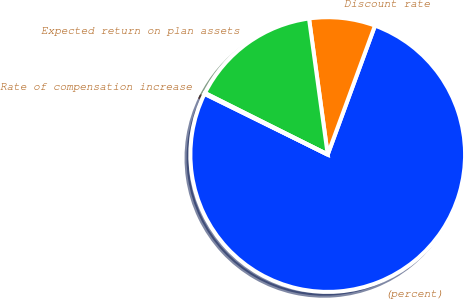Convert chart. <chart><loc_0><loc_0><loc_500><loc_500><pie_chart><fcel>(percent)<fcel>Discount rate<fcel>Expected return on plan assets<fcel>Rate of compensation increase<nl><fcel>76.7%<fcel>7.77%<fcel>15.43%<fcel>0.11%<nl></chart> 